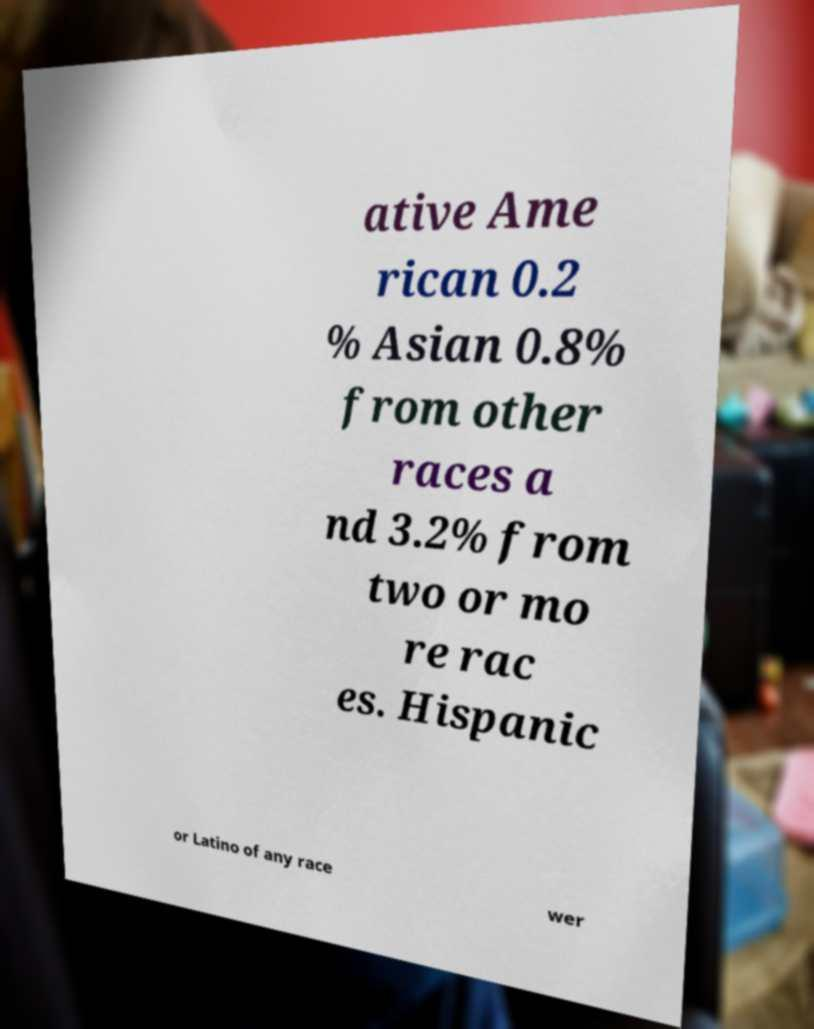There's text embedded in this image that I need extracted. Can you transcribe it verbatim? ative Ame rican 0.2 % Asian 0.8% from other races a nd 3.2% from two or mo re rac es. Hispanic or Latino of any race wer 